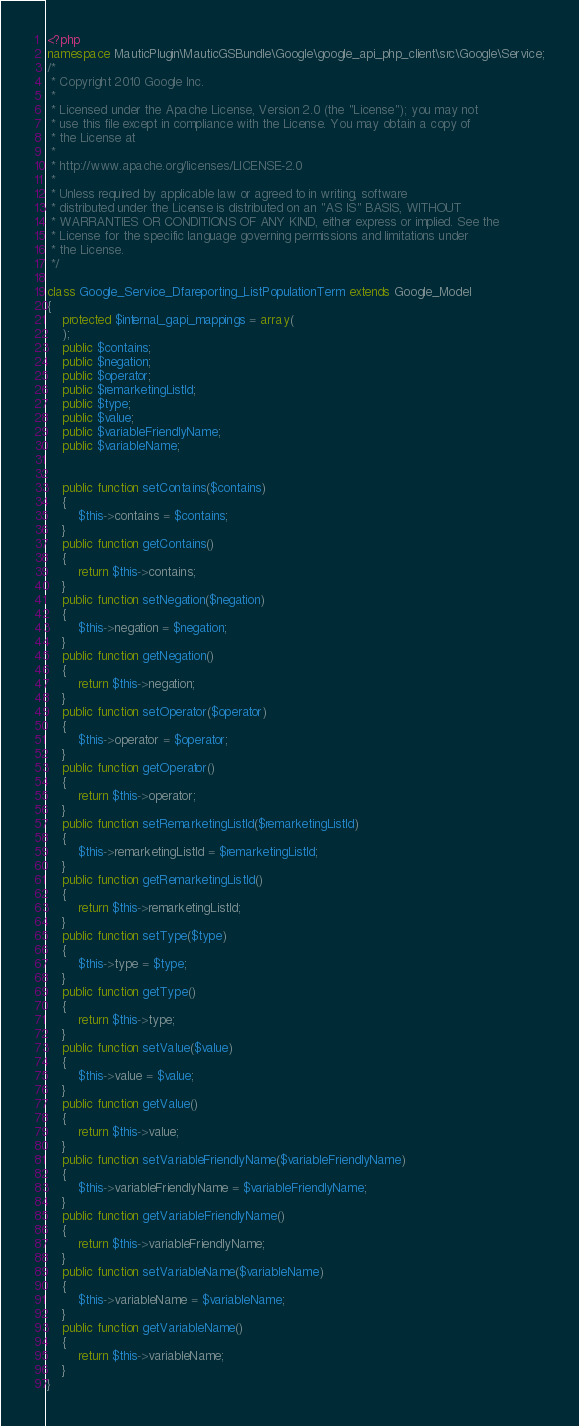Convert code to text. <code><loc_0><loc_0><loc_500><loc_500><_PHP_><?php
namespace MauticPlugin\MauticGSBundle\Google\google_api_php_client\src\Google\Service;
/*
 * Copyright 2010 Google Inc.
 *
 * Licensed under the Apache License, Version 2.0 (the "License"); you may not
 * use this file except in compliance with the License. You may obtain a copy of
 * the License at
 *
 * http://www.apache.org/licenses/LICENSE-2.0
 *
 * Unless required by applicable law or agreed to in writing, software
 * distributed under the License is distributed on an "AS IS" BASIS, WITHOUT
 * WARRANTIES OR CONDITIONS OF ANY KIND, either express or implied. See the
 * License for the specific language governing permissions and limitations under
 * the License.
 */

class Google_Service_Dfareporting_ListPopulationTerm extends Google_Model
{
    protected $internal_gapi_mappings = array(
    );
    public $contains;
    public $negation;
    public $operator;
    public $remarketingListId;
    public $type;
    public $value;
    public $variableFriendlyName;
    public $variableName;


    public function setContains($contains)
    {
        $this->contains = $contains;
    }
    public function getContains()
    {
        return $this->contains;
    }
    public function setNegation($negation)
    {
        $this->negation = $negation;
    }
    public function getNegation()
    {
        return $this->negation;
    }
    public function setOperator($operator)
    {
        $this->operator = $operator;
    }
    public function getOperator()
    {
        return $this->operator;
    }
    public function setRemarketingListId($remarketingListId)
    {
        $this->remarketingListId = $remarketingListId;
    }
    public function getRemarketingListId()
    {
        return $this->remarketingListId;
    }
    public function setType($type)
    {
        $this->type = $type;
    }
    public function getType()
    {
        return $this->type;
    }
    public function setValue($value)
    {
        $this->value = $value;
    }
    public function getValue()
    {
        return $this->value;
    }
    public function setVariableFriendlyName($variableFriendlyName)
    {
        $this->variableFriendlyName = $variableFriendlyName;
    }
    public function getVariableFriendlyName()
    {
        return $this->variableFriendlyName;
    }
    public function setVariableName($variableName)
    {
        $this->variableName = $variableName;
    }
    public function getVariableName()
    {
        return $this->variableName;
    }
}
</code> 